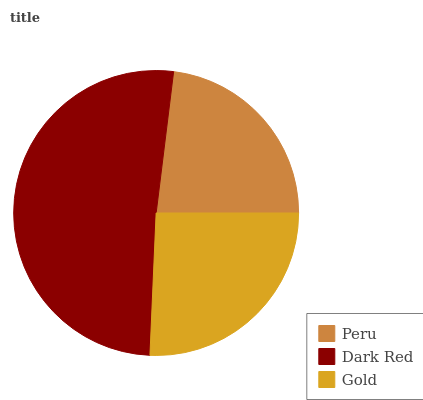Is Peru the minimum?
Answer yes or no. Yes. Is Dark Red the maximum?
Answer yes or no. Yes. Is Gold the minimum?
Answer yes or no. No. Is Gold the maximum?
Answer yes or no. No. Is Dark Red greater than Gold?
Answer yes or no. Yes. Is Gold less than Dark Red?
Answer yes or no. Yes. Is Gold greater than Dark Red?
Answer yes or no. No. Is Dark Red less than Gold?
Answer yes or no. No. Is Gold the high median?
Answer yes or no. Yes. Is Gold the low median?
Answer yes or no. Yes. Is Peru the high median?
Answer yes or no. No. Is Peru the low median?
Answer yes or no. No. 